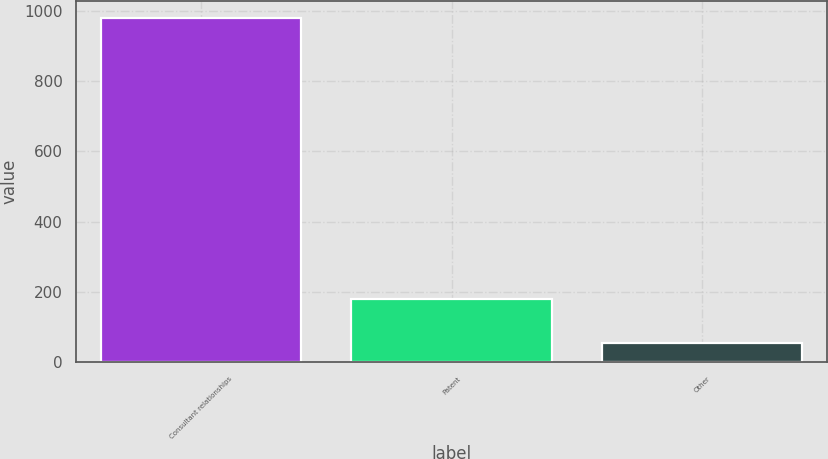Convert chart to OTSL. <chart><loc_0><loc_0><loc_500><loc_500><bar_chart><fcel>Consultant relationships<fcel>Patent<fcel>Other<nl><fcel>980<fcel>180<fcel>55<nl></chart> 